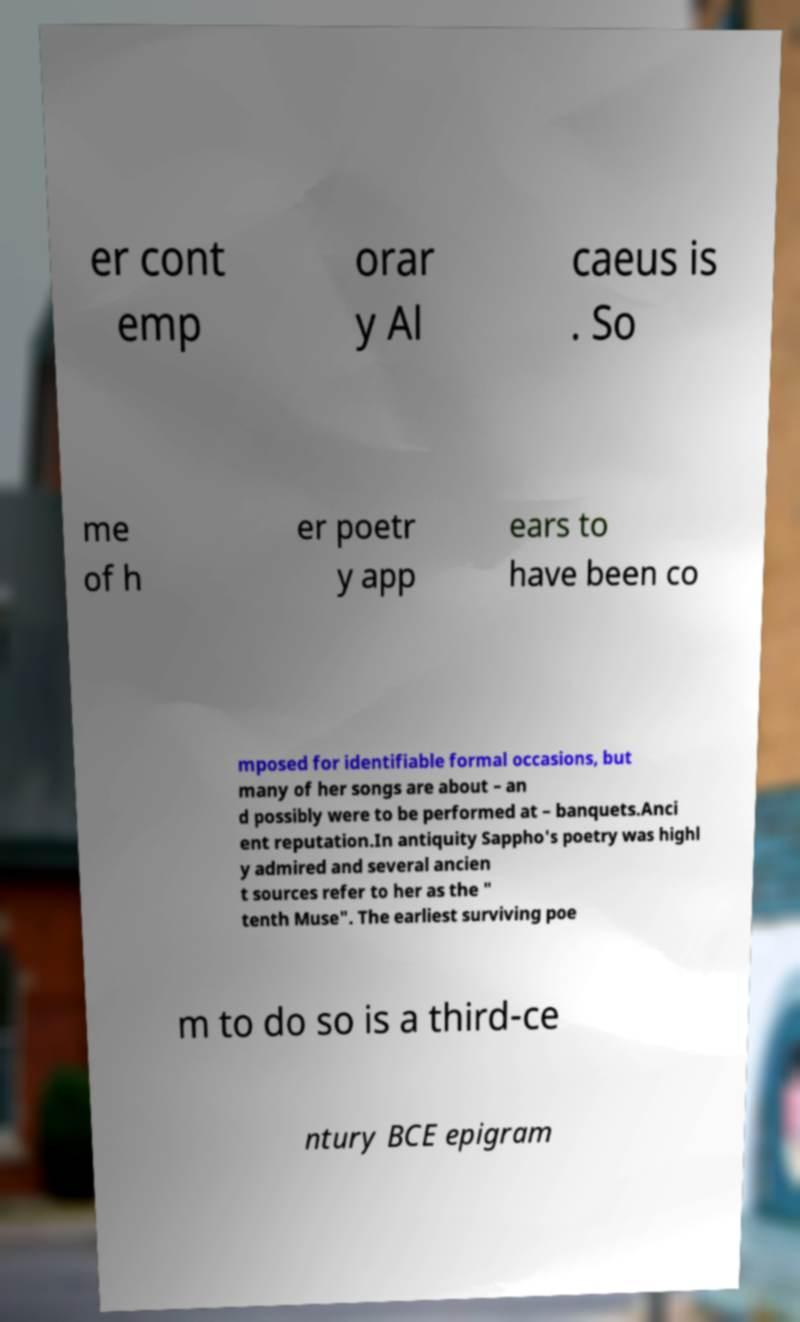Can you read and provide the text displayed in the image?This photo seems to have some interesting text. Can you extract and type it out for me? er cont emp orar y Al caeus is . So me of h er poetr y app ears to have been co mposed for identifiable formal occasions, but many of her songs are about – an d possibly were to be performed at – banquets.Anci ent reputation.In antiquity Sappho's poetry was highl y admired and several ancien t sources refer to her as the " tenth Muse". The earliest surviving poe m to do so is a third-ce ntury BCE epigram 